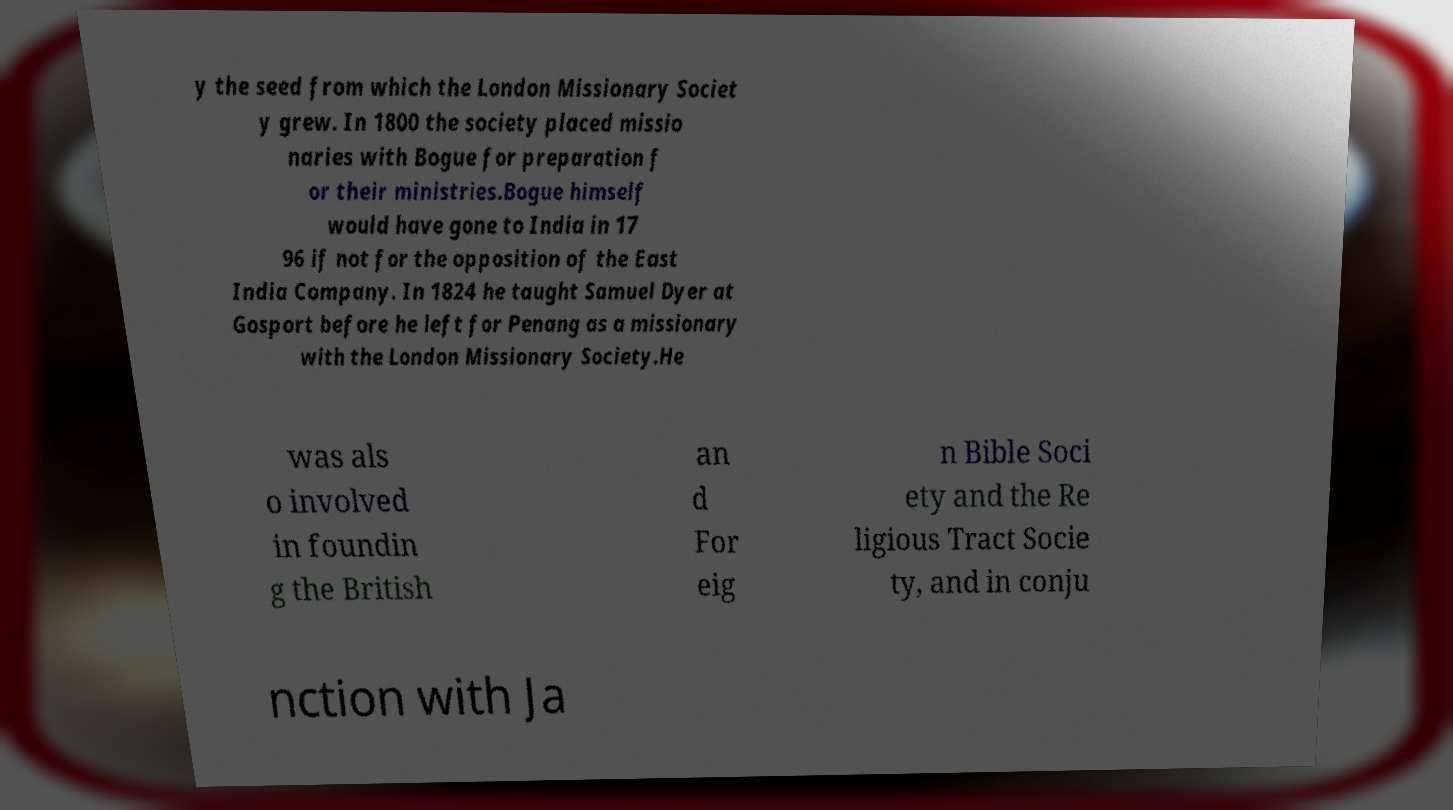Can you read and provide the text displayed in the image?This photo seems to have some interesting text. Can you extract and type it out for me? y the seed from which the London Missionary Societ y grew. In 1800 the society placed missio naries with Bogue for preparation f or their ministries.Bogue himself would have gone to India in 17 96 if not for the opposition of the East India Company. In 1824 he taught Samuel Dyer at Gosport before he left for Penang as a missionary with the London Missionary Society.He was als o involved in foundin g the British an d For eig n Bible Soci ety and the Re ligious Tract Socie ty, and in conju nction with Ja 